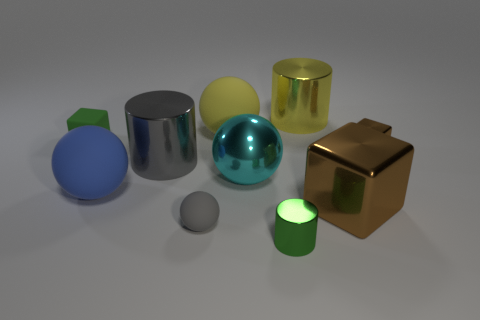Subtract all yellow cylinders. How many brown cubes are left? 2 Subtract all green cubes. How many cubes are left? 2 Subtract all yellow spheres. How many spheres are left? 3 Subtract 1 blocks. How many blocks are left? 2 Subtract all cylinders. How many objects are left? 7 Add 6 yellow cylinders. How many yellow cylinders exist? 7 Subtract 0 purple cylinders. How many objects are left? 10 Subtract all blue cylinders. Subtract all cyan cubes. How many cylinders are left? 3 Subtract all small shiny cubes. Subtract all small green cylinders. How many objects are left? 8 Add 5 tiny rubber blocks. How many tiny rubber blocks are left? 6 